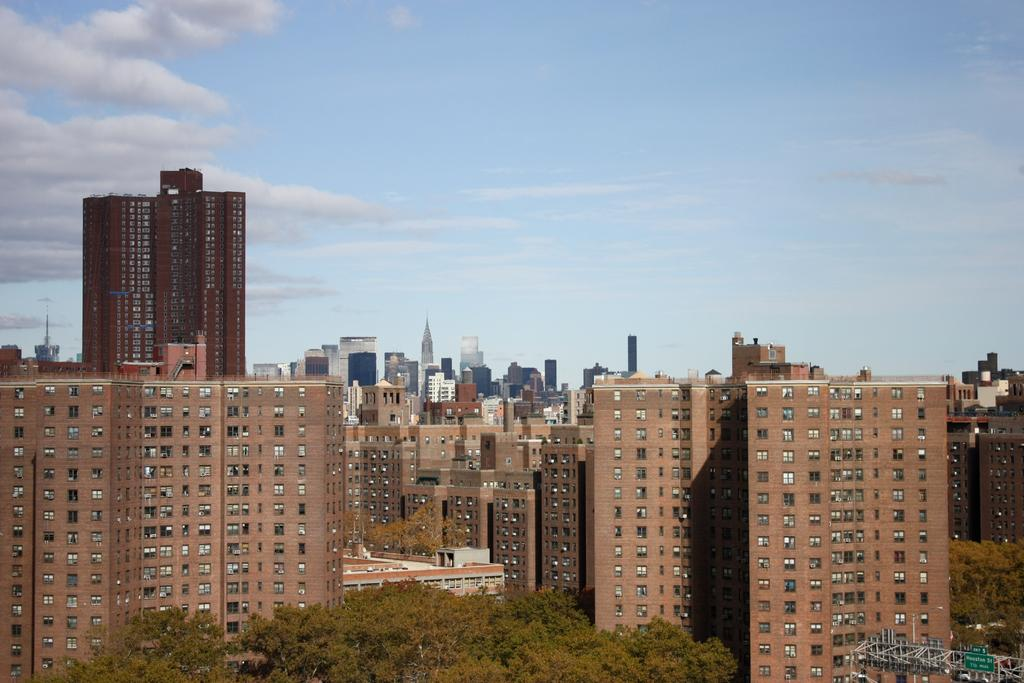What type of structures can be seen in the image? There are many buildings, skyscrapers, and towers visible in the image. What is visible at the top of the image? The sky is visible at the top of the image, and it contains clouds. What can be seen at the bottom of the image? Trees are visible at the bottom of the image. What type of acoustics can be heard in the image? There is no sound or acoustics present in the image, as it is a still photograph. How many rabbits are visible in the image? There are no rabbits present in the image. 